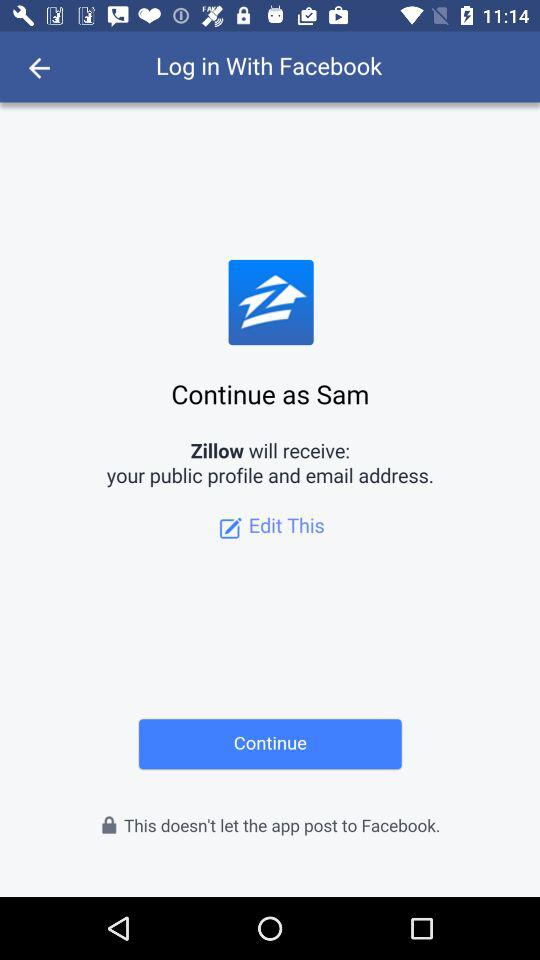What is the name of the user? The name of the user is Sam. 